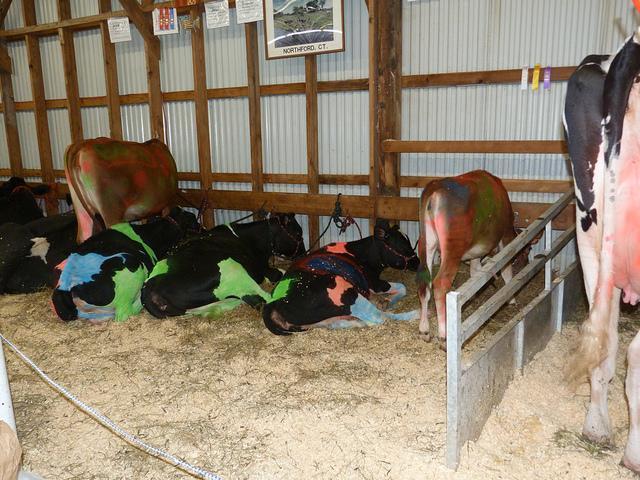What color is the black cow laying down to the right of the green cows?
Pick the right solution, then justify: 'Answer: answer
Rationale: rationale.'
Options: Pink, blue, gold, silver. Answer: pink.
Rationale: The color is pink. What made the cows unnatural colors?
Select the correct answer and articulate reasoning with the following format: 'Answer: answer
Rationale: rationale.'
Options: Spray paint, hair dye, crayons, markers. Answer: spray paint.
Rationale: They paint them to designate health status 